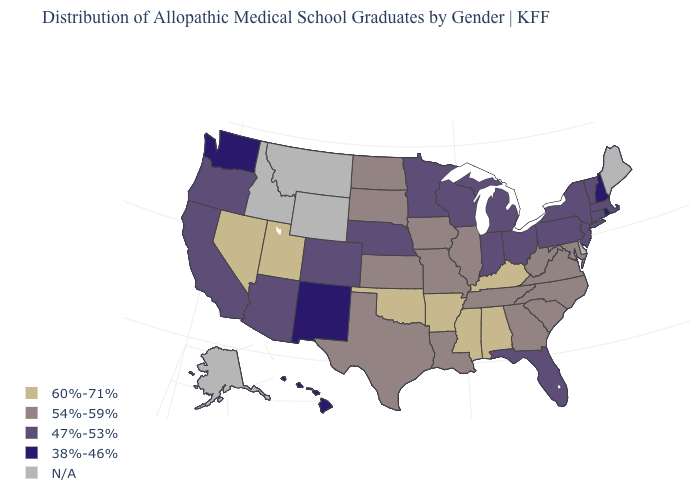Name the states that have a value in the range 38%-46%?
Answer briefly. Hawaii, New Hampshire, New Mexico, Rhode Island, Washington. Does the first symbol in the legend represent the smallest category?
Short answer required. No. Name the states that have a value in the range 47%-53%?
Concise answer only. Arizona, California, Colorado, Connecticut, Florida, Indiana, Massachusetts, Michigan, Minnesota, Nebraska, New Jersey, New York, Ohio, Oregon, Pennsylvania, Vermont, Wisconsin. Which states have the lowest value in the MidWest?
Short answer required. Indiana, Michigan, Minnesota, Nebraska, Ohio, Wisconsin. What is the lowest value in states that border New York?
Keep it brief. 47%-53%. Does the map have missing data?
Keep it brief. Yes. What is the value of Oregon?
Short answer required. 47%-53%. Which states have the highest value in the USA?
Short answer required. Alabama, Arkansas, Kentucky, Mississippi, Nevada, Oklahoma, Utah. What is the value of Hawaii?
Be succinct. 38%-46%. Does Florida have the highest value in the USA?
Concise answer only. No. Is the legend a continuous bar?
Be succinct. No. What is the lowest value in the USA?
Keep it brief. 38%-46%. What is the highest value in the MidWest ?
Give a very brief answer. 54%-59%. What is the value of Missouri?
Answer briefly. 54%-59%. 